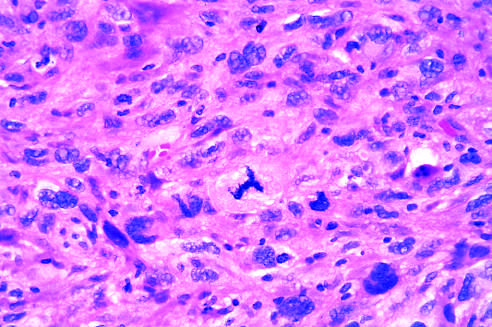what shows cellular and nuclear variation in size and shape?
Answer the question using a single word or phrase. Anaplastic tumor cells 